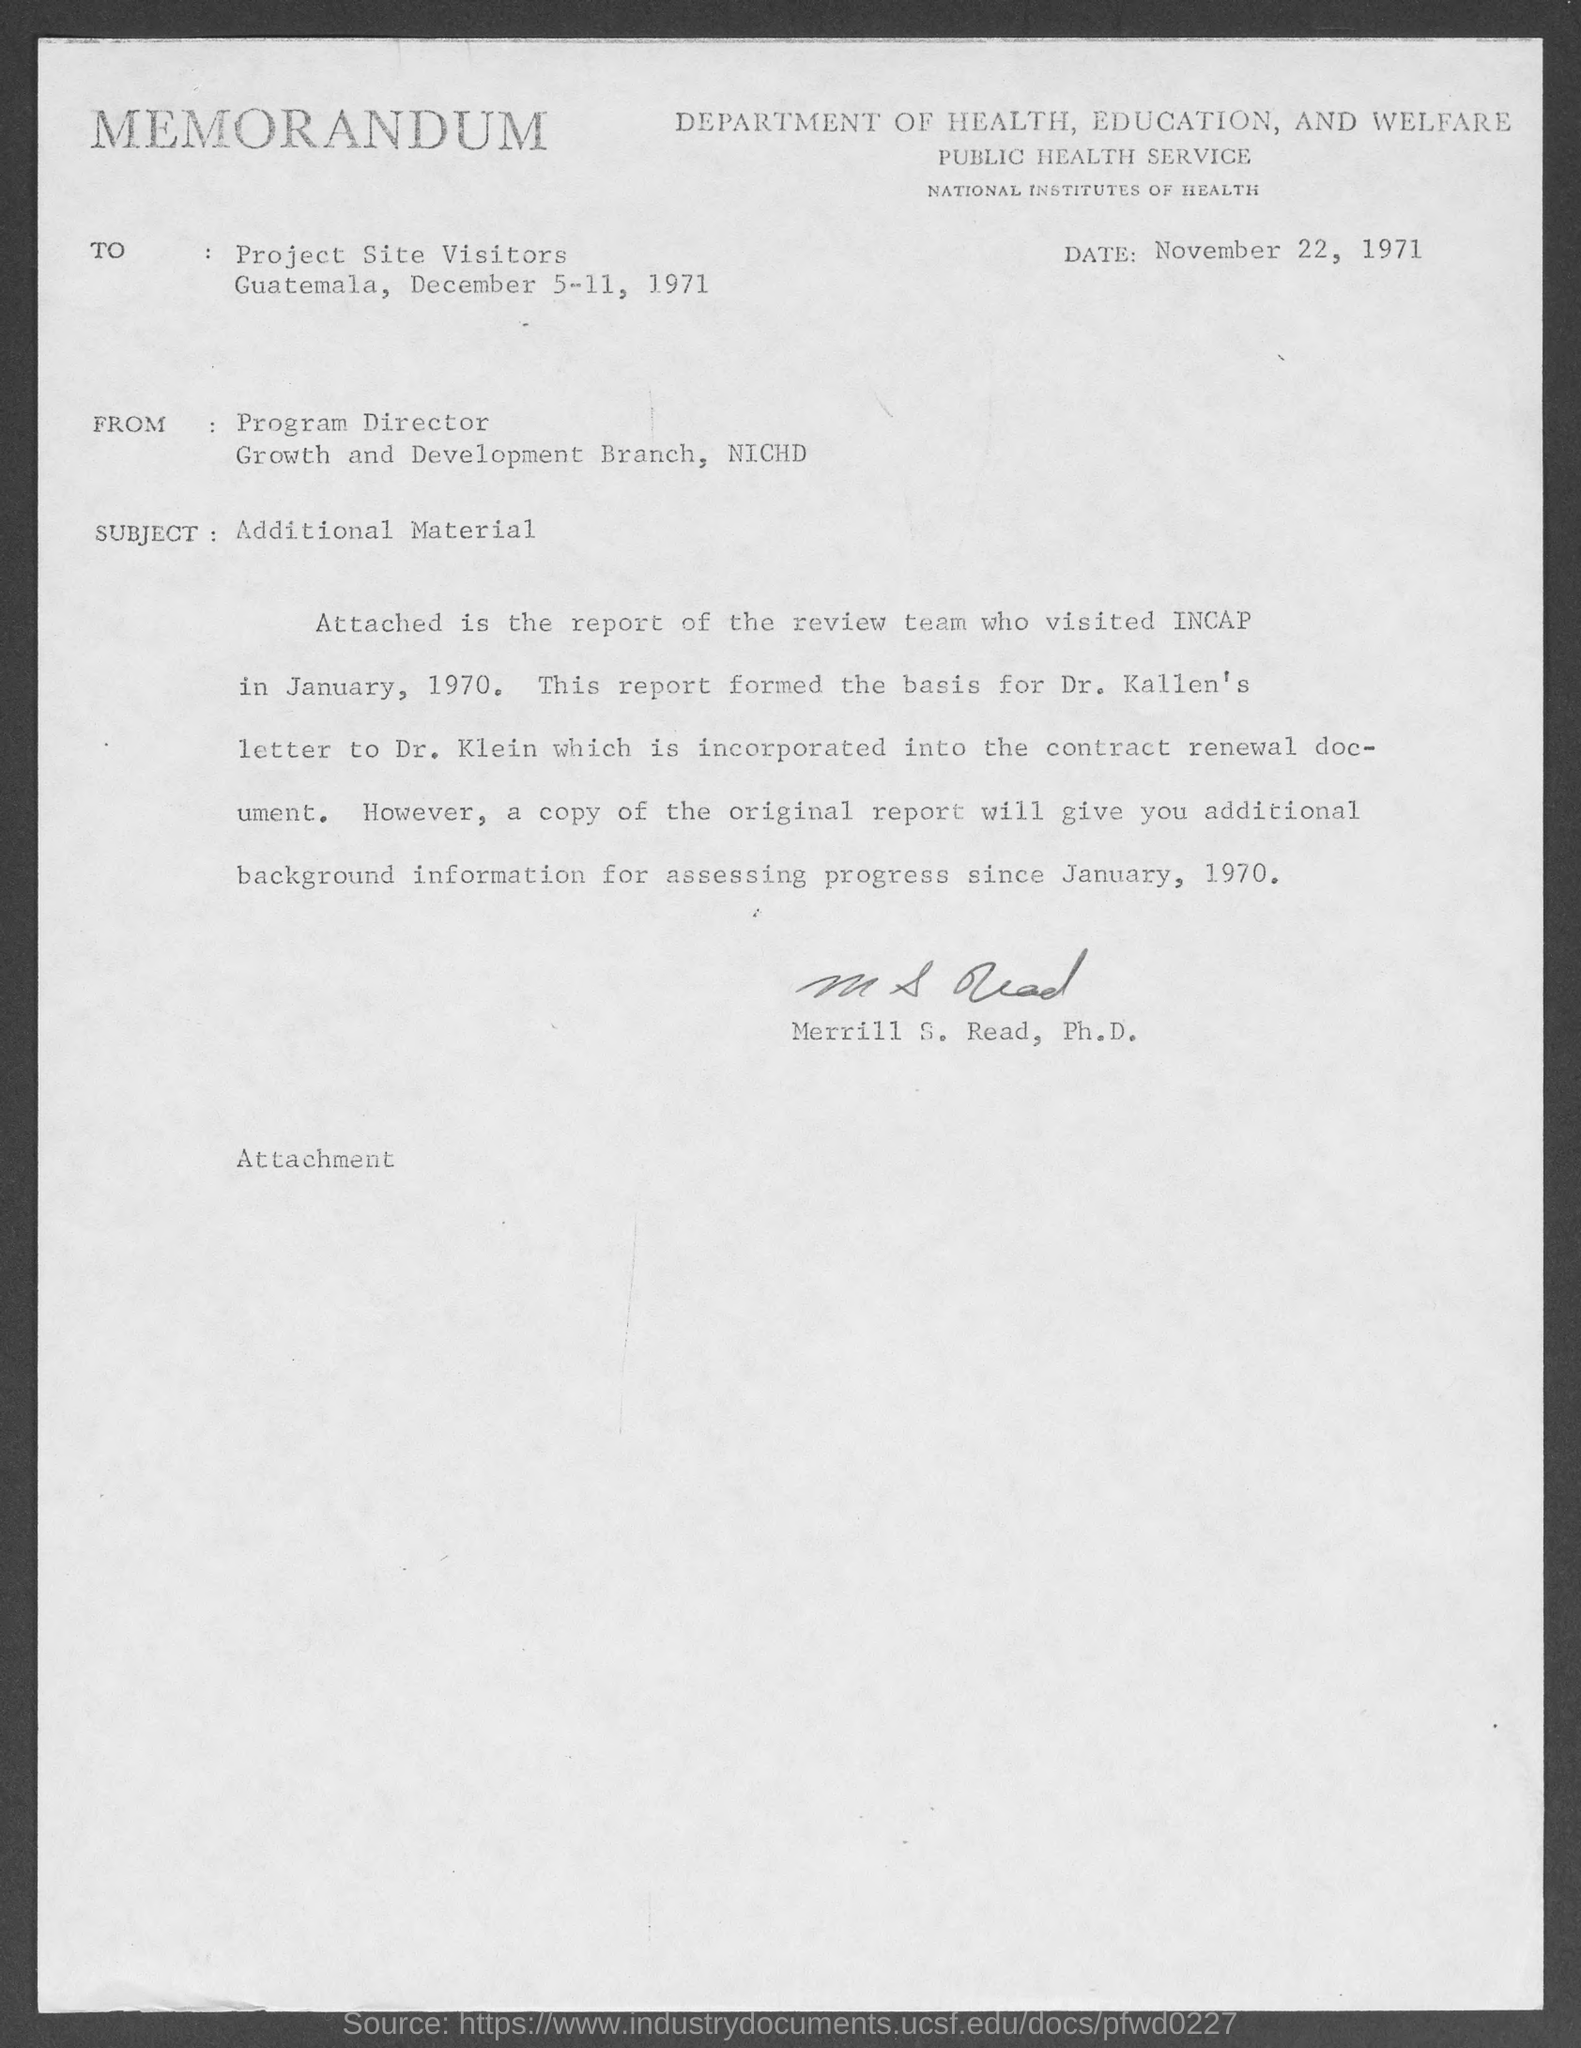Outline some significant characteristics in this image. The memorandum states that the date mentioned is November 22, 1971. The memorandum has been signed by Merrill S. Read, Ph.D. The memorandum is addressed to Project Site Visitors. The subject of this memorandum is additional material. This is a memorandum, a type of communication that serves as a record of information and is typically used for internal purposes within an organization. 